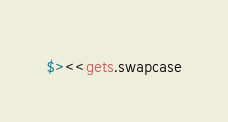<code> <loc_0><loc_0><loc_500><loc_500><_Ruby_>$><<gets.swapcase</code> 